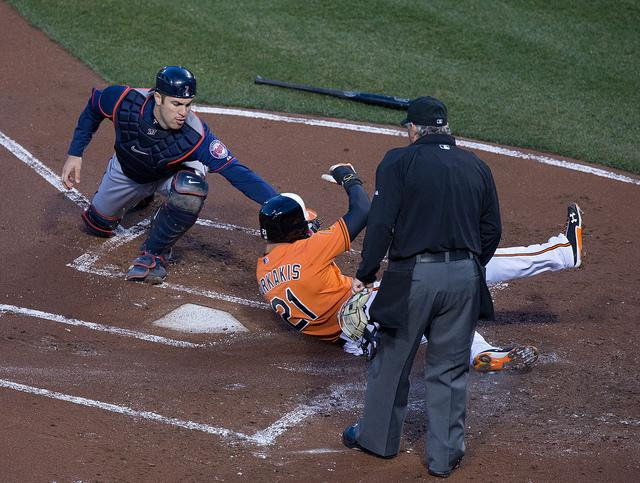What is the position of the man who is standing? umpire 